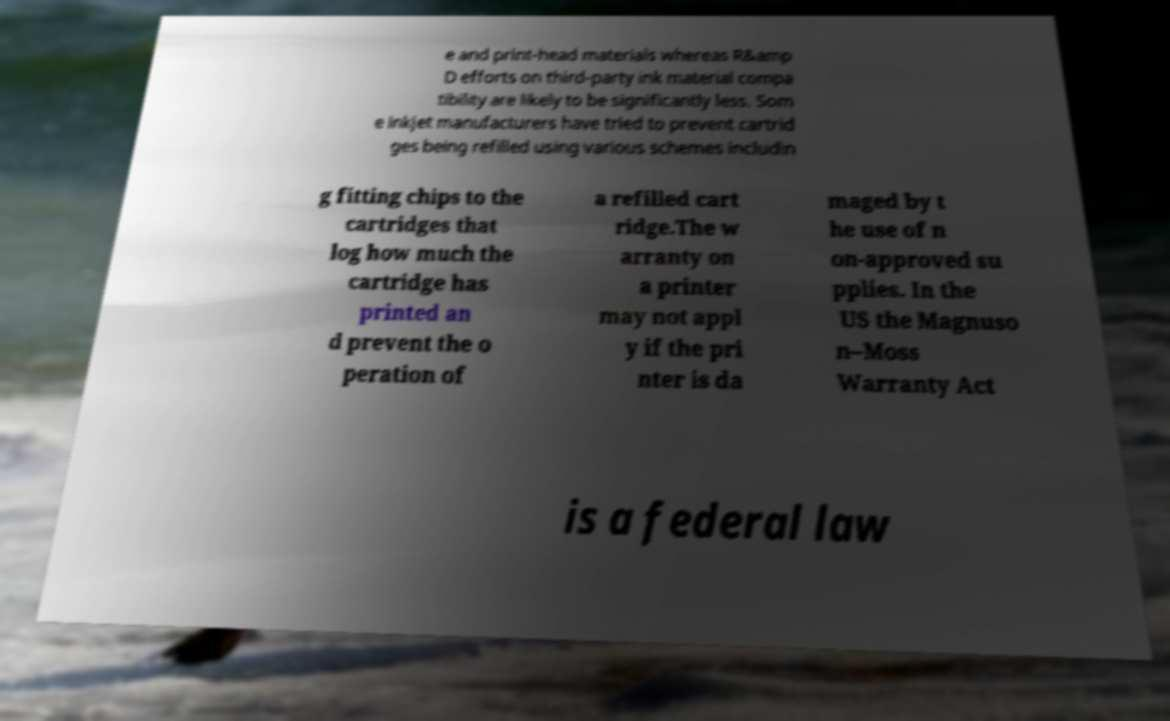Please read and relay the text visible in this image. What does it say? e and print-head materials whereas R&amp D efforts on third-party ink material compa tibility are likely to be significantly less. Som e inkjet manufacturers have tried to prevent cartrid ges being refilled using various schemes includin g fitting chips to the cartridges that log how much the cartridge has printed an d prevent the o peration of a refilled cart ridge.The w arranty on a printer may not appl y if the pri nter is da maged by t he use of n on-approved su pplies. In the US the Magnuso n–Moss Warranty Act is a federal law 